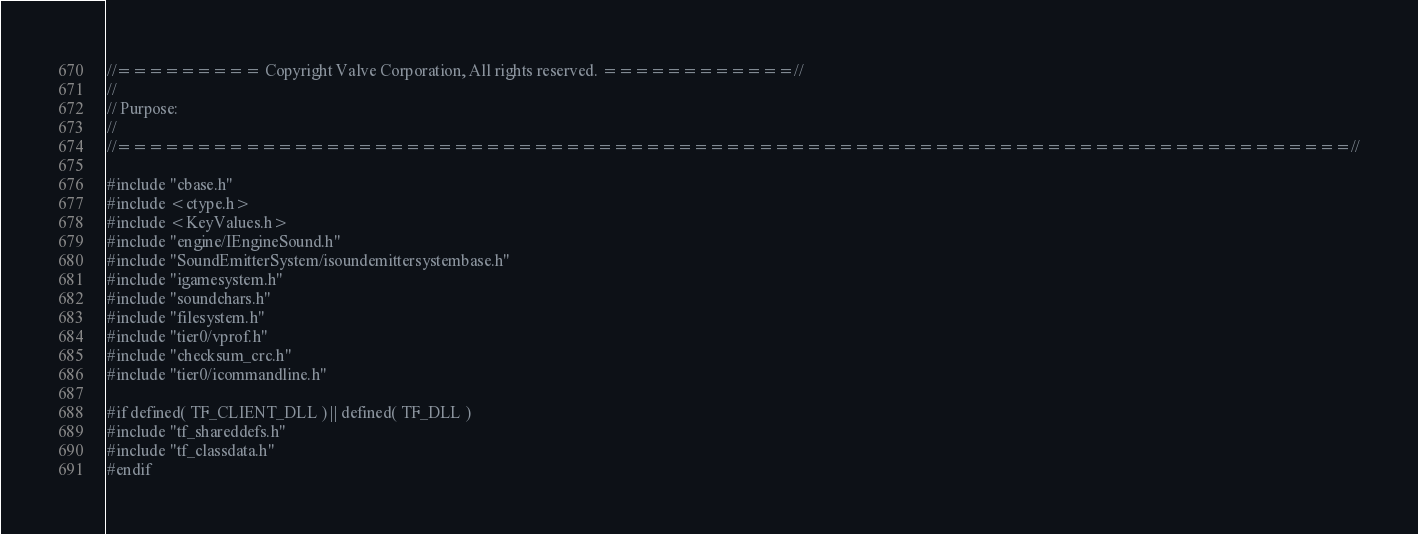<code> <loc_0><loc_0><loc_500><loc_500><_C++_>//========= Copyright Valve Corporation, All rights reserved. ============//
//
// Purpose: 
//
//=============================================================================//

#include "cbase.h"
#include <ctype.h>
#include <KeyValues.h>
#include "engine/IEngineSound.h"
#include "SoundEmitterSystem/isoundemittersystembase.h"
#include "igamesystem.h"
#include "soundchars.h"
#include "filesystem.h"
#include "tier0/vprof.h"
#include "checksum_crc.h"
#include "tier0/icommandline.h"

#if defined( TF_CLIENT_DLL ) || defined( TF_DLL )
#include "tf_shareddefs.h"
#include "tf_classdata.h"
#endif
</code> 